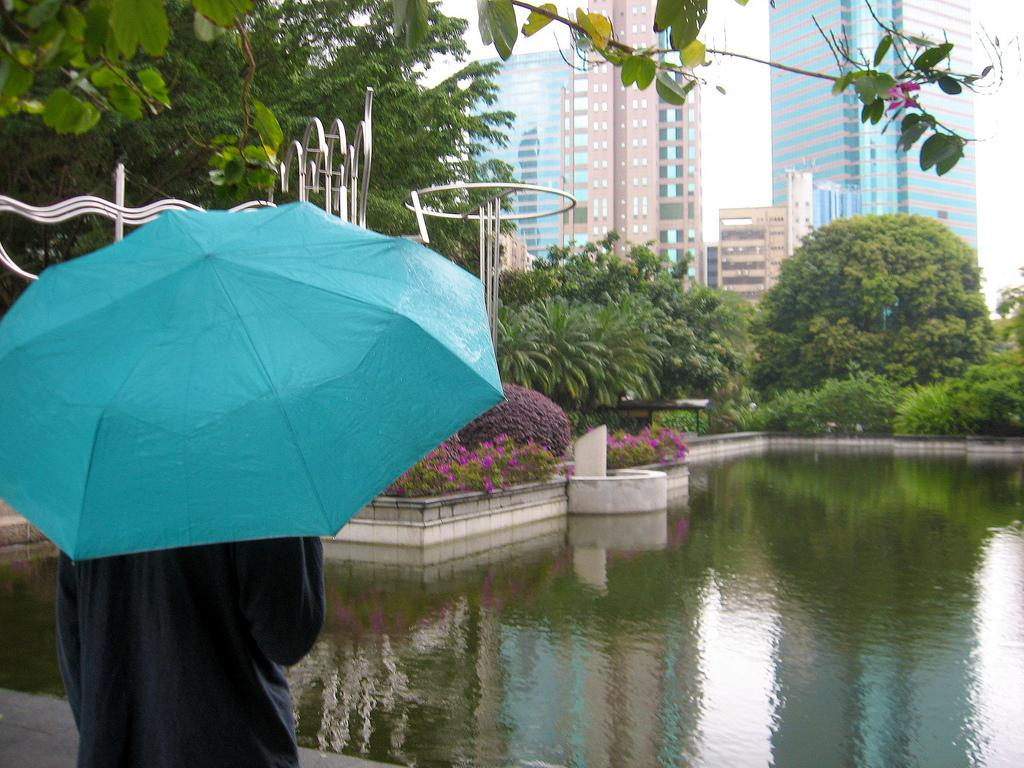Question: what is the person holding?
Choices:
A. A coat.
B. An umbrella.
C. A puppy.
D. A bag of food.
Answer with the letter. Answer: B Question: why is the person looking at the city?
Choices:
A. It is run down.
B. It is beautiful.
C. It is covered in snow.
D. It is huge.
Answer with the letter. Answer: B Question: when does this take place?
Choices:
A. The morning.
B. The evening.
C. At midnight.
D. The middle of the day.
Answer with the letter. Answer: D Question: how was this picture taken?
Choices:
A. With a camera.
B. With a cell-phone.
C. With a computer.
D. With two cameras.
Answer with the letter. Answer: A Question: who is the subject of the photo?
Choices:
A. The person with the umbrella.
B. The person with the cane.
C. The person with the hat.
D. The person with the baseball.
Answer with the letter. Answer: A Question: what is behind the pool?
Choices:
A. Dirt.
B. Cement.
C. Water.
D. Plants.
Answer with the letter. Answer: D Question: what is the pool filled with?
Choices:
A. Mud.
B. Water.
C. Cement.
D. Dirt.
Answer with the letter. Answer: B Question: where was this photo taken?
Choices:
A. In the country.
B. In a city.
C. In the woods.
D. On the ocean.
Answer with the letter. Answer: B Question: what is open?
Choices:
A. The photo album.
B. The door.
C. The refrigerator.
D. The umbrella.
Answer with the letter. Answer: D Question: how is the pond water moving?
Choices:
A. It is choppy.
B. It is smooth.
C. It is still.
D. It is tranquil.
Answer with the letter. Answer: C Question: what is in the background?
Choices:
A. Large trees.
B. Train station.
C. Tall buildings.
D. Bus station.
Answer with the letter. Answer: C Question: what color is the umbrella?
Choices:
A. Purple.
B. Black.
C. Blue-green.
D. Red.
Answer with the letter. Answer: C Question: what is in the bushes?
Choices:
A. Strawberries.
B. Blueberries.
C. Seeds.
D. Flowers.
Answer with the letter. Answer: D Question: what kind of day is it?
Choices:
A. Cloudy.
B. Sunny.
C. Rainy.
D. Snowy.
Answer with the letter. Answer: B Question: what kind of artwork is by the pond?
Choices:
A. Silver metal.
B. Bronze statue.
C. Small statues.
D. Golden metal.
Answer with the letter. Answer: A Question: what do the building have a lot of?
Choices:
A. Windows.
B. Floors.
C. Employees.
D. Occupants.
Answer with the letter. Answer: A Question: what can be seen on the water?
Choices:
A. Waves.
B. Ripples.
C. Floating logs.
D. Reflections.
Answer with the letter. Answer: D 